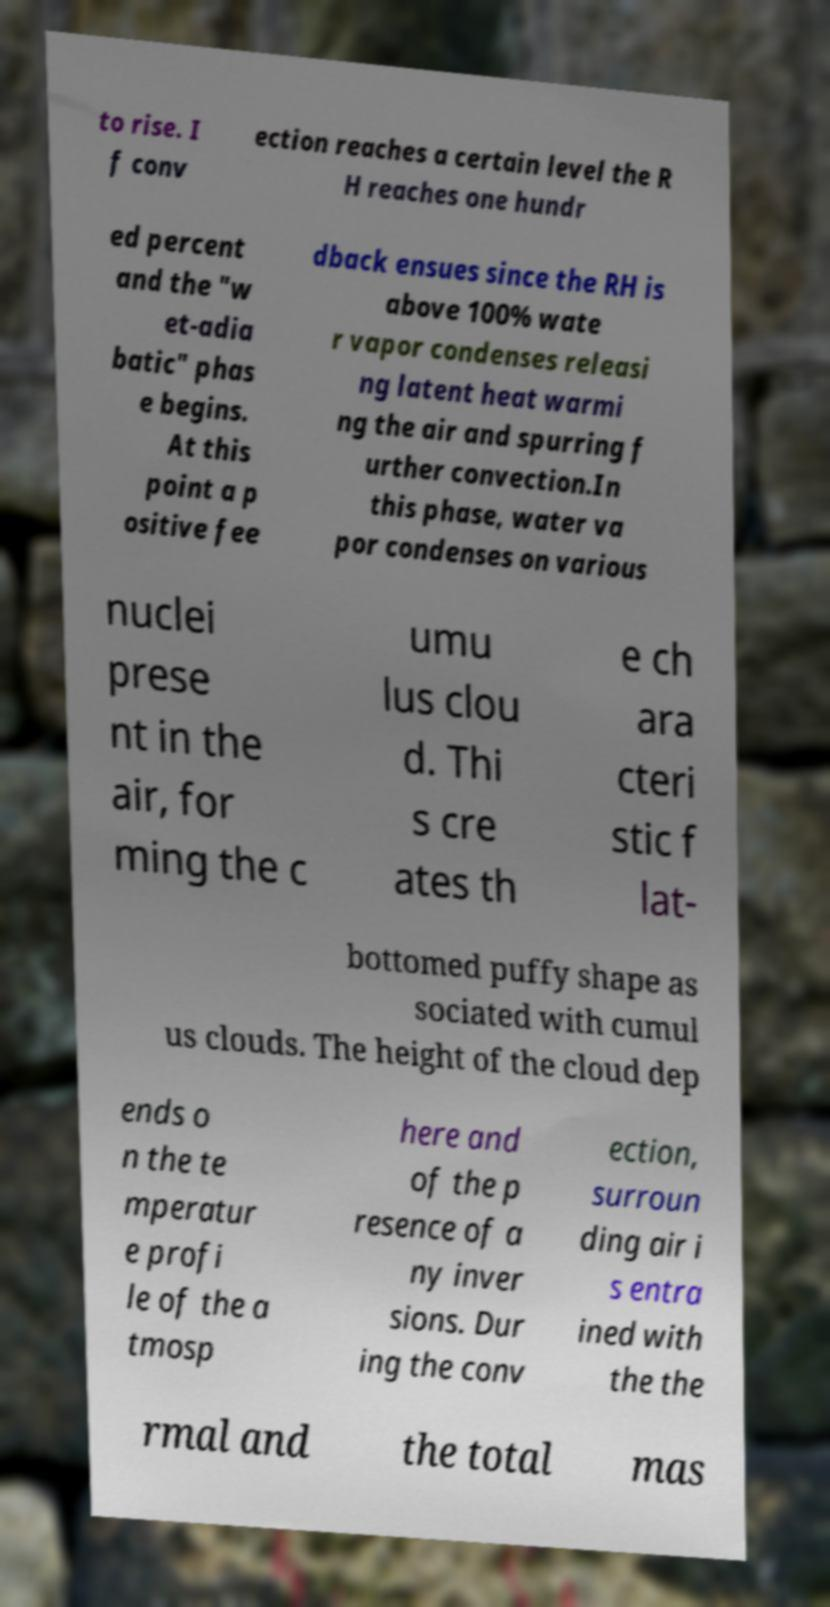Please read and relay the text visible in this image. What does it say? to rise. I f conv ection reaches a certain level the R H reaches one hundr ed percent and the "w et-adia batic" phas e begins. At this point a p ositive fee dback ensues since the RH is above 100% wate r vapor condenses releasi ng latent heat warmi ng the air and spurring f urther convection.In this phase, water va por condenses on various nuclei prese nt in the air, for ming the c umu lus clou d. Thi s cre ates th e ch ara cteri stic f lat- bottomed puffy shape as sociated with cumul us clouds. The height of the cloud dep ends o n the te mperatur e profi le of the a tmosp here and of the p resence of a ny inver sions. Dur ing the conv ection, surroun ding air i s entra ined with the the rmal and the total mas 